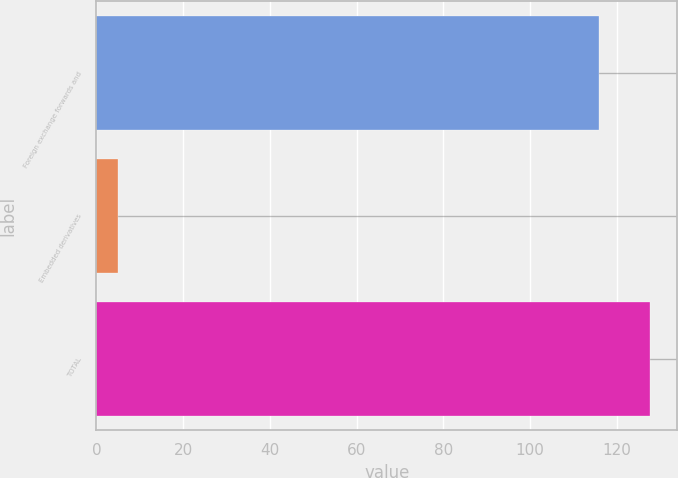Convert chart to OTSL. <chart><loc_0><loc_0><loc_500><loc_500><bar_chart><fcel>Foreign exchange forwards and<fcel>Embedded derivatives<fcel>TOTAL<nl><fcel>116<fcel>5<fcel>127.6<nl></chart> 